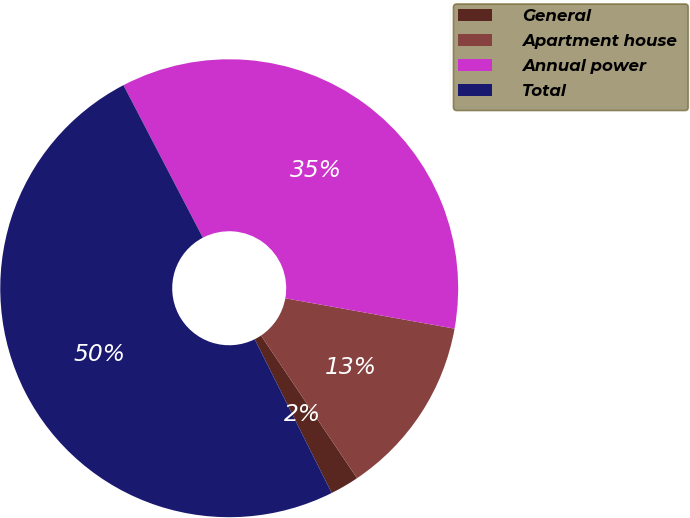Convert chart to OTSL. <chart><loc_0><loc_0><loc_500><loc_500><pie_chart><fcel>General<fcel>Apartment house<fcel>Annual power<fcel>Total<nl><fcel>2.04%<fcel>12.75%<fcel>35.47%<fcel>49.75%<nl></chart> 